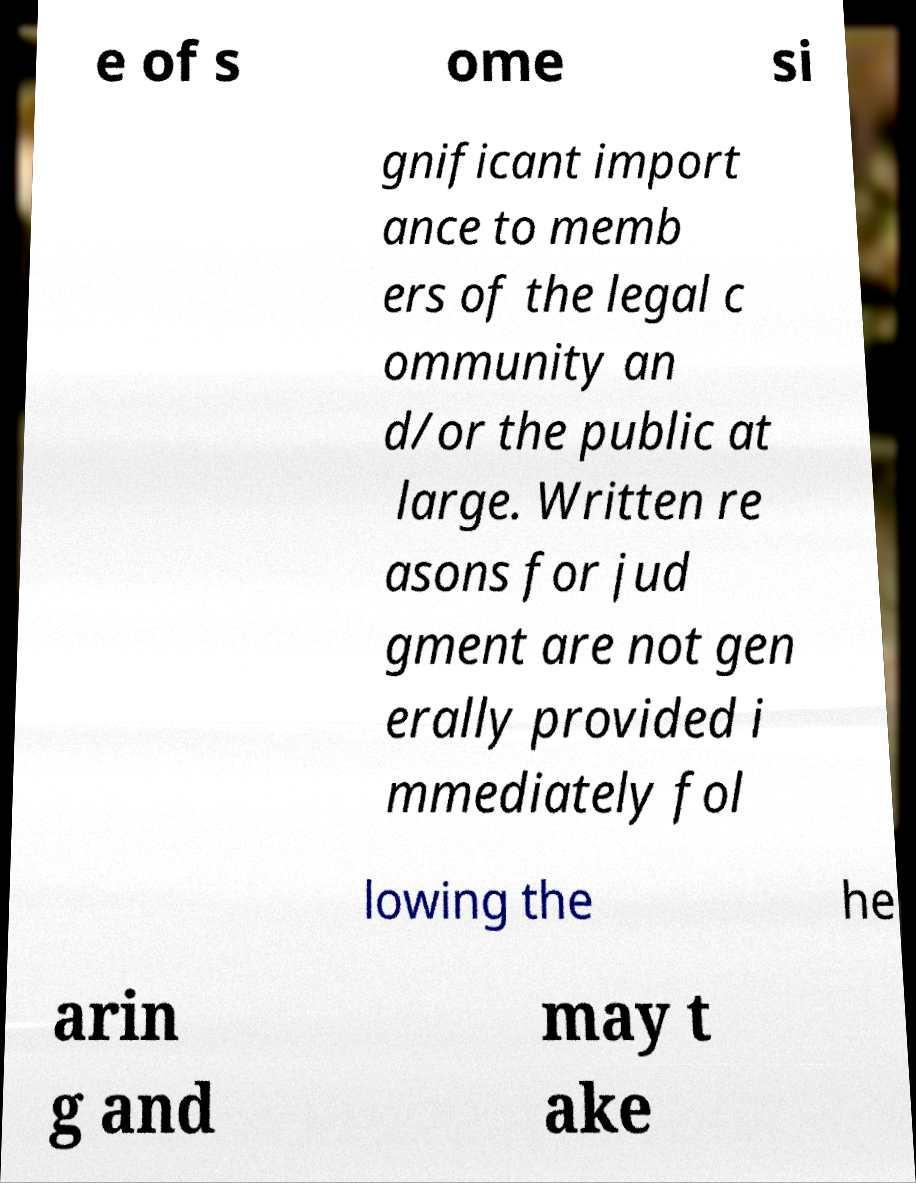There's text embedded in this image that I need extracted. Can you transcribe it verbatim? e of s ome si gnificant import ance to memb ers of the legal c ommunity an d/or the public at large. Written re asons for jud gment are not gen erally provided i mmediately fol lowing the he arin g and may t ake 